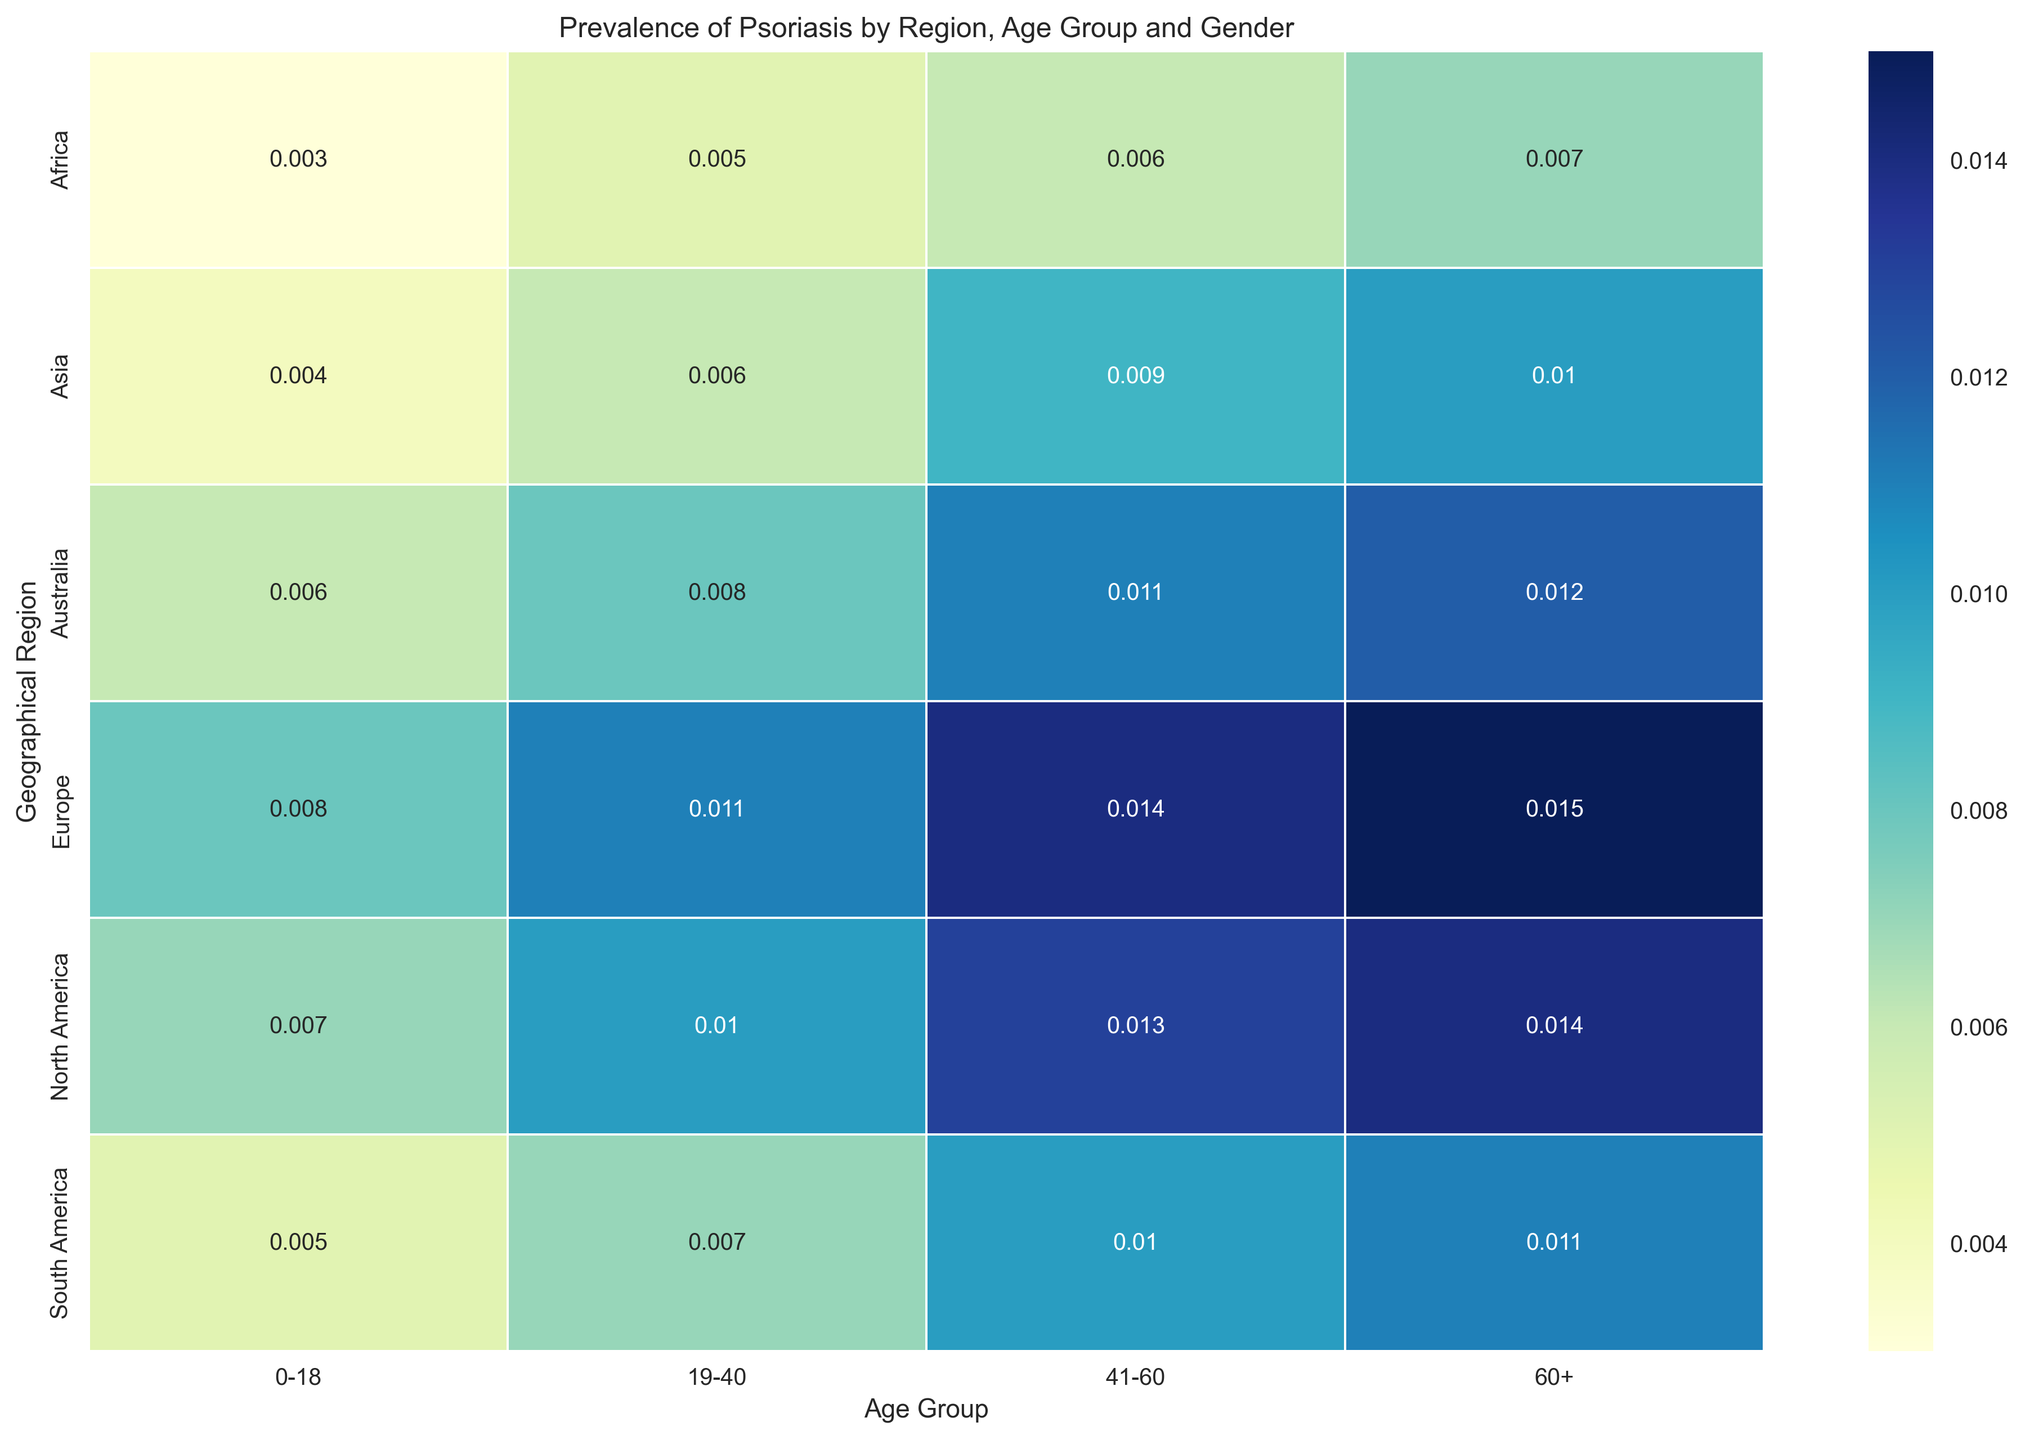What is the prevalence rate of psoriasis in North America for ages 19-40 Females? By reading the cell that intersects "North America" in the row and "19-40" in the column under "Female", the value is 0.010. Therefore, the prevalence rate is 1.0% (when converted to percentage).
Answer: 1.0% Which region shows the lowest prevalence rate for males aged 0-18? We need to compare the values in the heatmap for males aged 0-18 across all regions. The lowest value is found in Africa with a prevalence rate of 0.4%.
Answer: Africa How does the prevalence of psoriasis in Europe for ages 60+ Females compare to that in Asia for the same age and gender group? Looking at the cells where Europe and Asia intersect with "60+" under "Female", the values are 0.015 (Europe) and 0.010 (Asia). Europe has a higher prevalence rate compared to Asia.
Answer: Europe has a higher prevalence rate What is the difference in psoriasis prevalence rates between males and females aged 41-60 in South America? Identify the cells for "South America" intersecting with "41-60" under both "Male" and "Female". The values are 0.012 for males and 0.010 for females. The difference is 0.012 - 0.010 = 0.002.
Answer: 0.002 or 0.2% Which age group shows the highest prevalence rate of psoriasis in Australia for females? We need to compare the cells under "Australia" and different "Age Groups". The highest value is 0.012 for "60+" age group for females.
Answer: 60+ What are the average prevalence rates of psoriasis for males across all regions for the age group 19-40? Sum the values for males aged 19-40 across all regions (1.2%, 1.3%, 0.8%, 0.6%, 0.9%, 1.0%) and divide by the number of regions (6). The average prevalence rate is (0.012 + 0.013 + 0.008 + 0.006 + 0.009 + 0.010) / 6 = 0.058 / 6 = 0.0096 or 0.96%.
Answer: 0.96% Is there a noticeable trend in the prevalence rates of psoriasis in North America as age increases for both genders? Looking at the values for North America across different age groups for both genders, we see an increasing trend from 0.8% (0-18) to 1.6% (60+) for males and 0.7% (0-18) to 1.4% (60+) for females.
Answer: Yes, increasing trend Which geographical region has the most consistent prevalence rate of psoriasis across all age groups for females? Consistent means having little variation in values. Look at the columns for each region under "Female". Asia has the prevalence rates of 0.004, 0.006, 0.009, 0.010 which shows the smallest variation compared to others.
Answer: Asia 